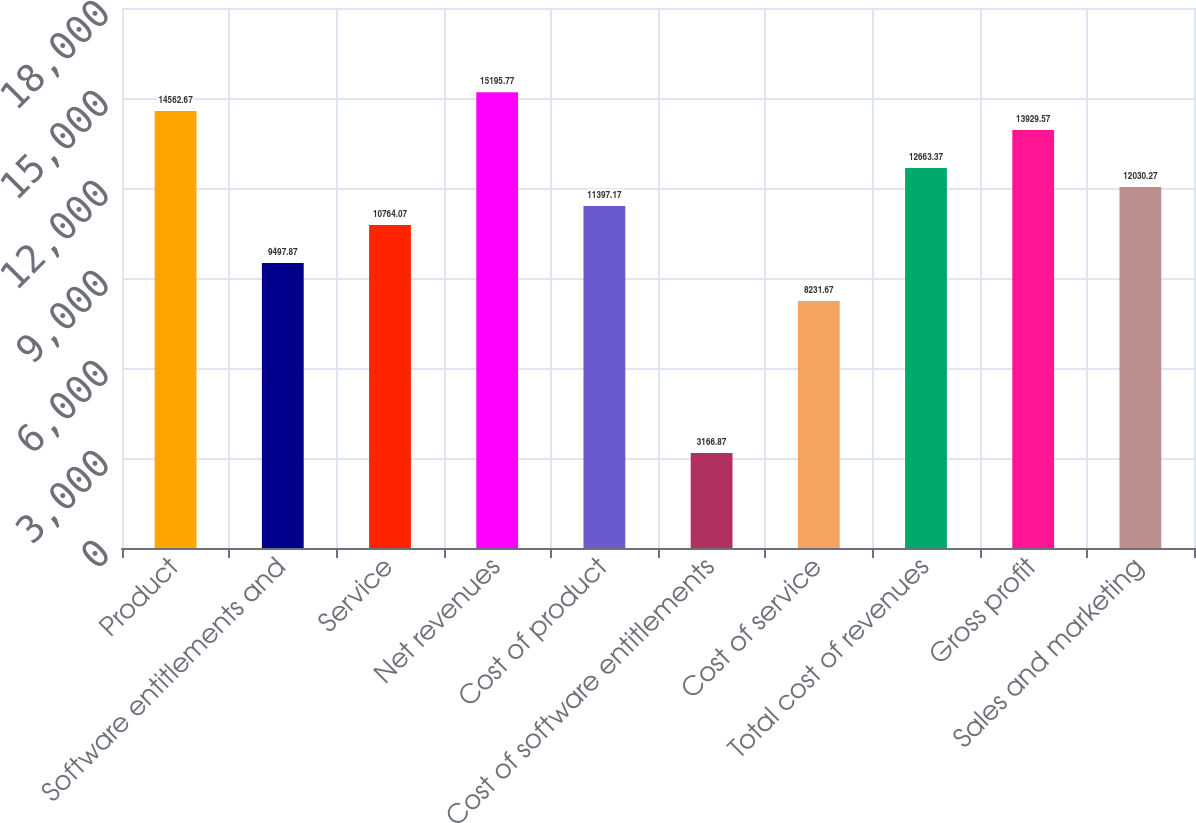Convert chart to OTSL. <chart><loc_0><loc_0><loc_500><loc_500><bar_chart><fcel>Product<fcel>Software entitlements and<fcel>Service<fcel>Net revenues<fcel>Cost of product<fcel>Cost of software entitlements<fcel>Cost of service<fcel>Total cost of revenues<fcel>Gross profit<fcel>Sales and marketing<nl><fcel>14562.7<fcel>9497.87<fcel>10764.1<fcel>15195.8<fcel>11397.2<fcel>3166.87<fcel>8231.67<fcel>12663.4<fcel>13929.6<fcel>12030.3<nl></chart> 